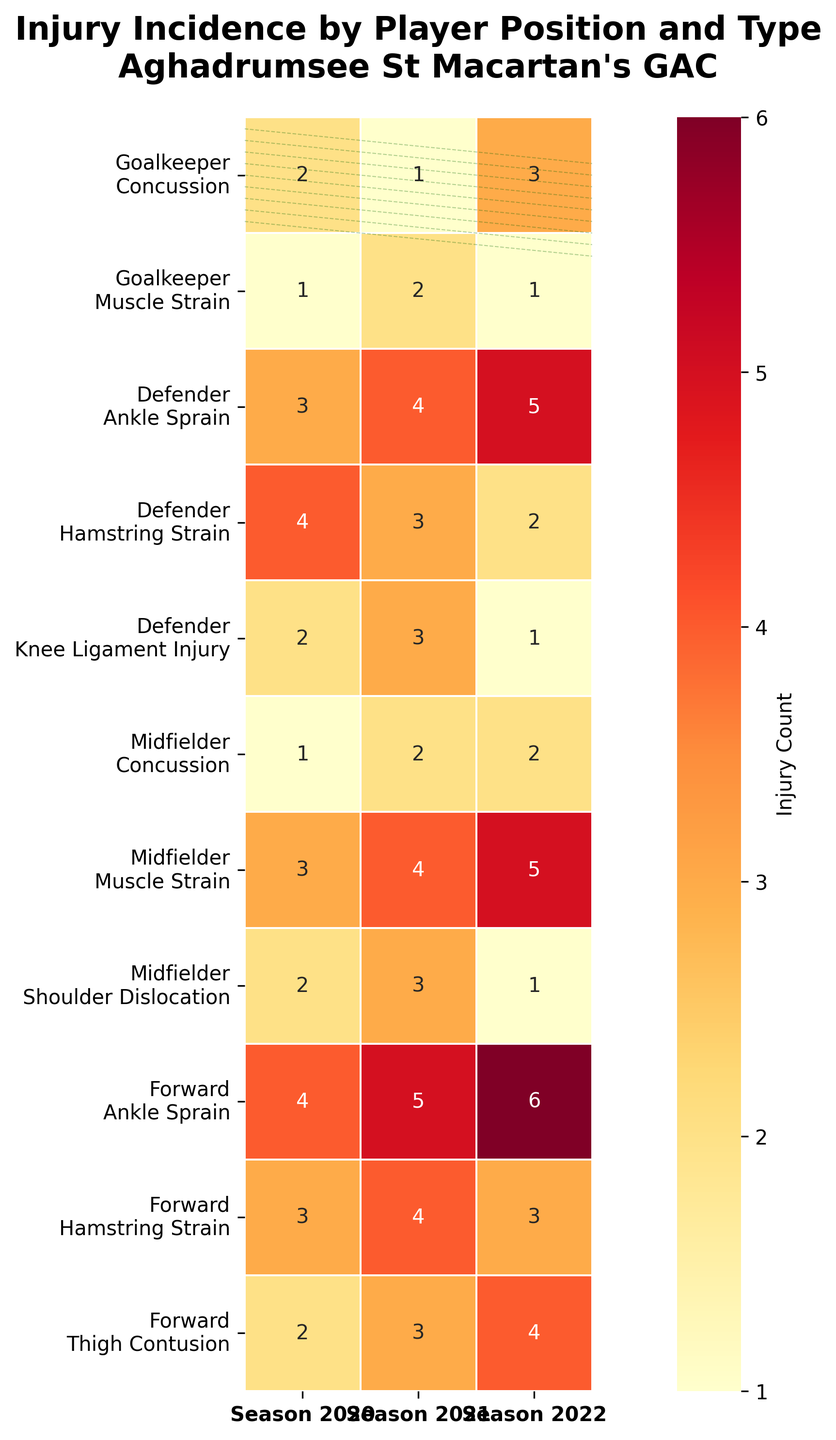What is the highest number of injuries for Goalkeepers in any season? Locate the Goalkeeper entries in the heatmap. Then, compare the injury counts across Seasons 2020, 2021, and 2022 for each type. The highest number of injuries for Goalkeepers is 3, which occurs with concussions in Season 2022.
Answer: 3 Which player position had the highest number of muscle strains in Season 2022? Find the column for Season 2022 and the rows corresponding to Muscle Strains for each position. The highest number is 5, which occurs for Midfielders.
Answer: Midfielders How many ankle sprains did Defenders have over all three seasons combined? Find the entries for Defenders with Ankle Sprains across Seasons 2020, 2021, and 2022. Add the values: 3 (2020) + 4 (2021) + 5 (2022) = 12.
Answer: 12 Which injury type has a higher count for Forwards in Season 2021: Hamstring Strains or Thigh Contusions? Compare the counts for Forward's Hamstring Strains and Thigh Contusions in Season 2021. Hamstring Strains have 4, and Thigh Contusions have 3. Therefore, Hamstring Strains have a higher count.
Answer: Hamstring Strains What is the sum of concussions for Midfielders across all seasons? Locate the Midfielder row for Concussions and sum the values for 2020, 2021, and 2022. The values are 1 (2020) + 2 (2021) + 2 (2022) = 5.
Answer: 5 Which season had the highest total number of injuries for all positions? Sum the total injuries across all positions and types for each season: 
- Season 2020: Sum all entries in the first column.
- Season 2021: Sum all entries in the second column.
- Season 2022: Sum all entries in the third column.
Calculate each sum: 
Season 2020: (2 + 1 + 3 + 4 + 2 + 1 + 3 + 2 + 4 + 3 + 2) = 27
Season 2021: (1 + 2 + 4 + 3 + 3 + 2 + 4 + 3 + 5 + 4 + 3) = 34
Season 2022: (3 + 1 + 5 + 2 + 1 + 2 + 5 + 1 + 6 + 3 + 4) = 33
The highest count is 34 in Season 2021.
Answer: Season 2021 How many more injuries of Muscle Strains did Defenders have compared to Goalkeepers in Season 2021? Find the number of Muscle Strains for Defenders and Goalkeepers in Season 2021 from the heatmap. The numbers are 4 for Defenders and 2 for Goalkeepers. The difference is 4 - 2 = 2.
Answer: 2 Which player position had the most diverse types of injuries? Count the distinct injury types for each player position. Goalkeepers have 2 distinct types, Defenders have 3, Midfielders have 3, and Forwards have 3 distinct types. Hence, Defenders, Midfielders, and Forwards are equally diverse in injury types.
Answer: Defenders, Midfielders, Forwards Which type of injury showed a consistent increase in frequency for Forwards over the seasons? Observe the Forward's entries for each type of injury across all seasons, looking for a consistent increase. Ankle Sprains for Forwards increased from 4 (2020) to 5 (2021) to 6 (2022).
Answer: Ankle Sprains 